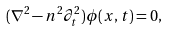<formula> <loc_0><loc_0><loc_500><loc_500>( \nabla ^ { 2 } - n ^ { 2 } \partial _ { t } ^ { 2 } ) \phi ( x , t ) = 0 ,</formula> 